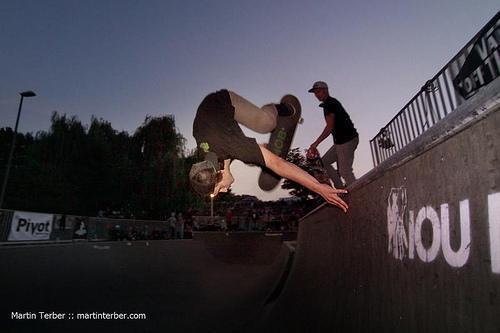How many men are there?
Give a very brief answer. 2. 